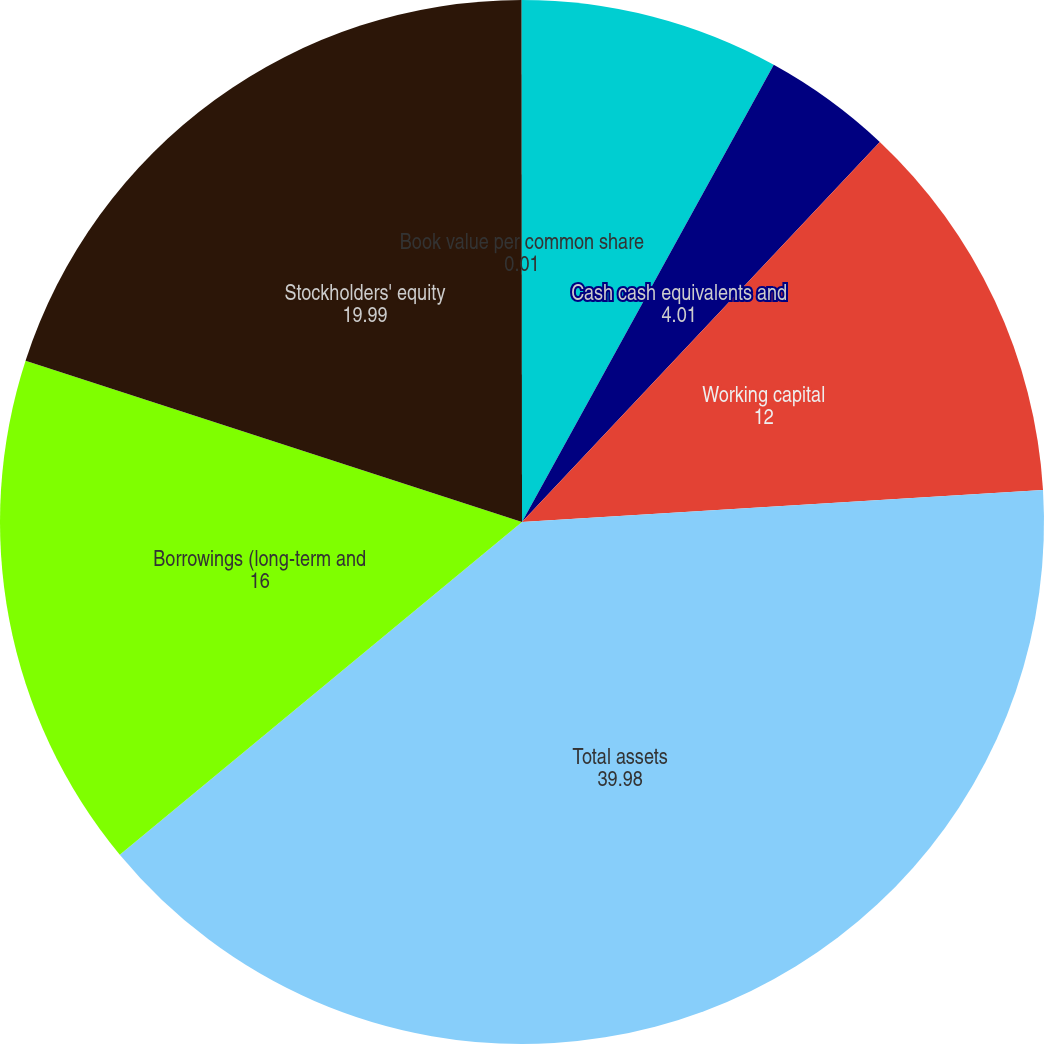<chart> <loc_0><loc_0><loc_500><loc_500><pie_chart><fcel>As of December 31<fcel>Cash cash equivalents and<fcel>Working capital<fcel>Total assets<fcel>Borrowings (long-term and<fcel>Stockholders' equity<fcel>Book value per common share<nl><fcel>8.01%<fcel>4.01%<fcel>12.0%<fcel>39.98%<fcel>16.0%<fcel>19.99%<fcel>0.01%<nl></chart> 